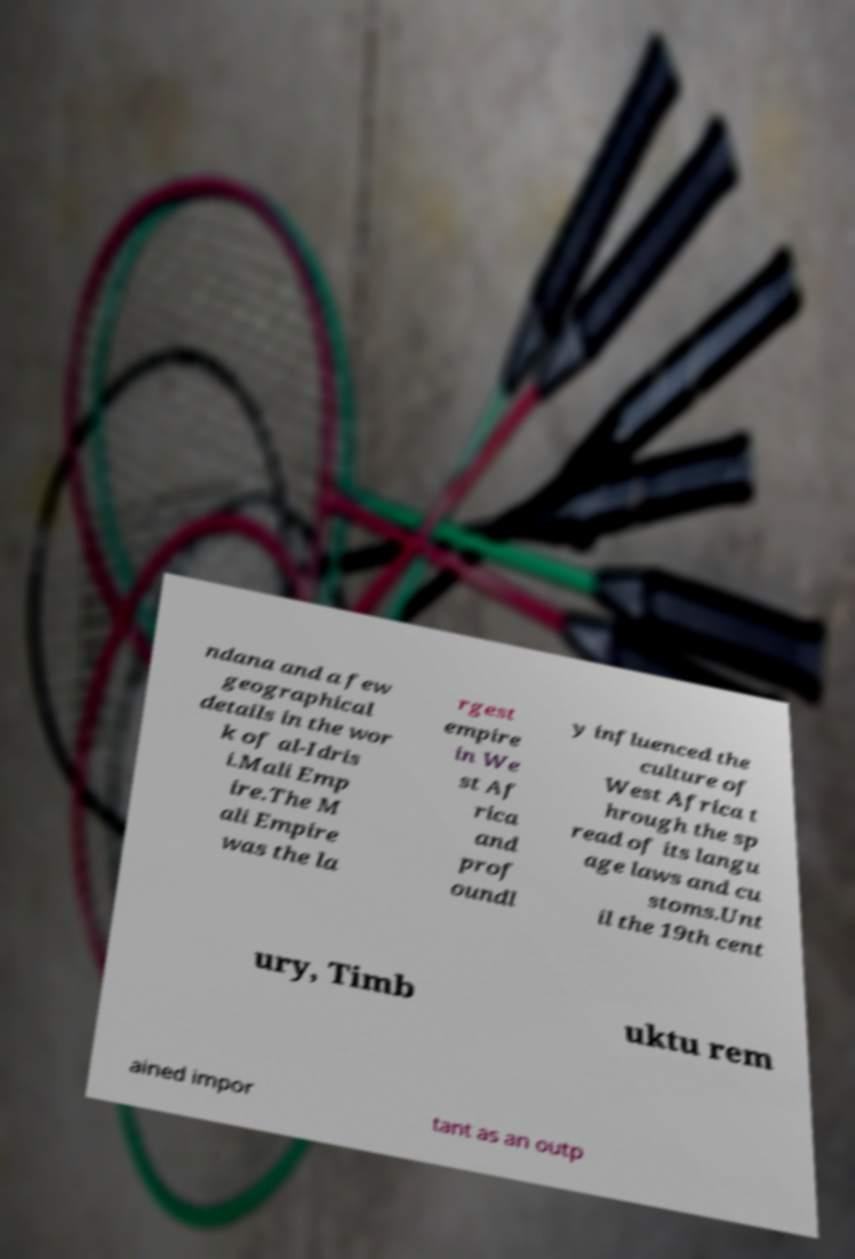There's text embedded in this image that I need extracted. Can you transcribe it verbatim? ndana and a few geographical details in the wor k of al-Idris i.Mali Emp ire.The M ali Empire was the la rgest empire in We st Af rica and prof oundl y influenced the culture of West Africa t hrough the sp read of its langu age laws and cu stoms.Unt il the 19th cent ury, Timb uktu rem ained impor tant as an outp 